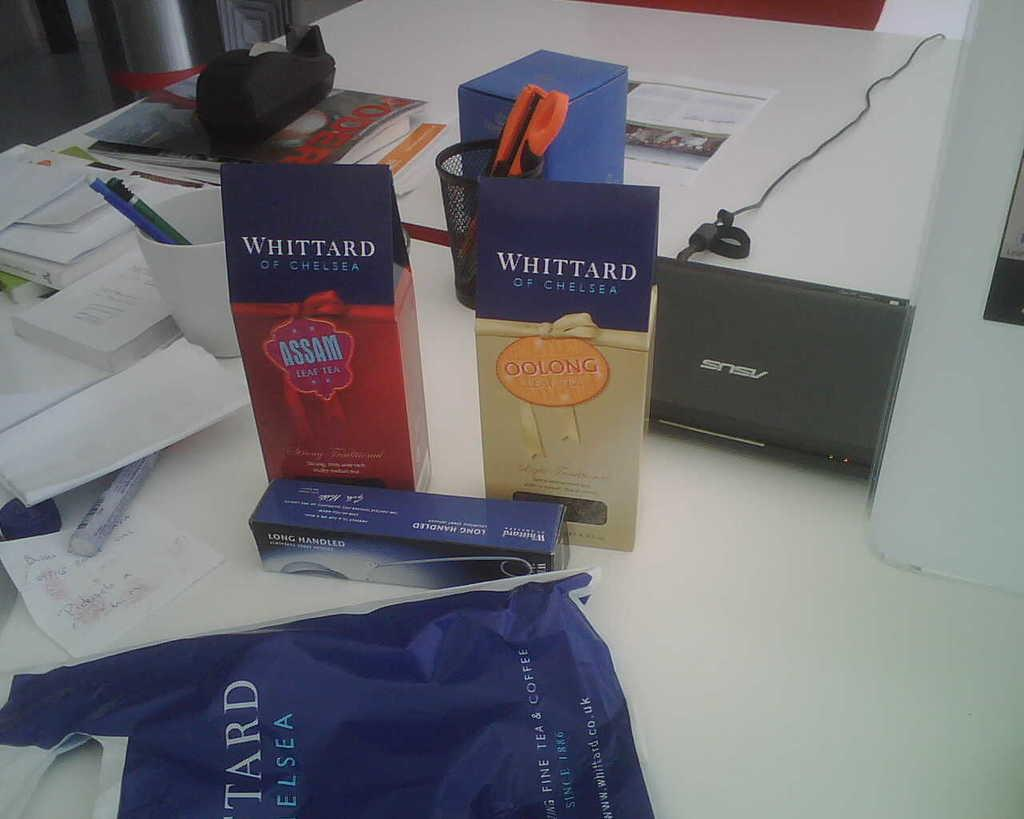<image>
Write a terse but informative summary of the picture. A table with a laptop and a plastic bag is sitting beside some boxes that one of which says Whittard Of Chelsea Oolong on it. 